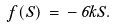Convert formula to latex. <formula><loc_0><loc_0><loc_500><loc_500>f ( S ) \, = \, - \, 6 k S .</formula> 